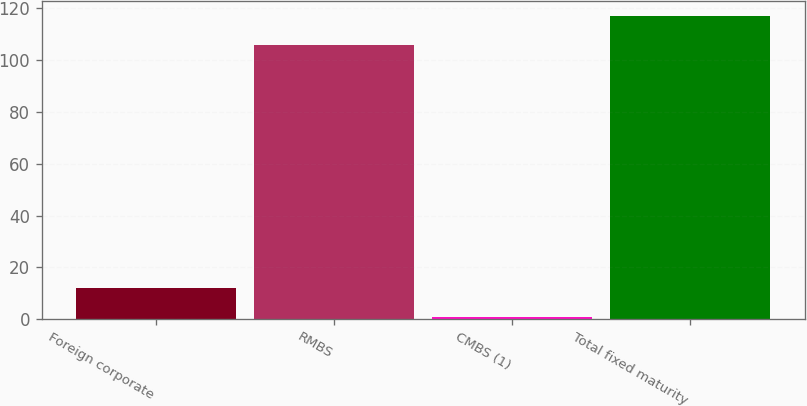<chart> <loc_0><loc_0><loc_500><loc_500><bar_chart><fcel>Foreign corporate<fcel>RMBS<fcel>CMBS (1)<fcel>Total fixed maturity<nl><fcel>12.1<fcel>106<fcel>1<fcel>117.1<nl></chart> 